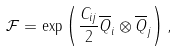<formula> <loc_0><loc_0><loc_500><loc_500>\mathcal { F } = \exp \left ( \frac { C _ { i j } } { 2 } \overline { Q } _ { i } \otimes \overline { Q } _ { j } \right ) ,</formula> 